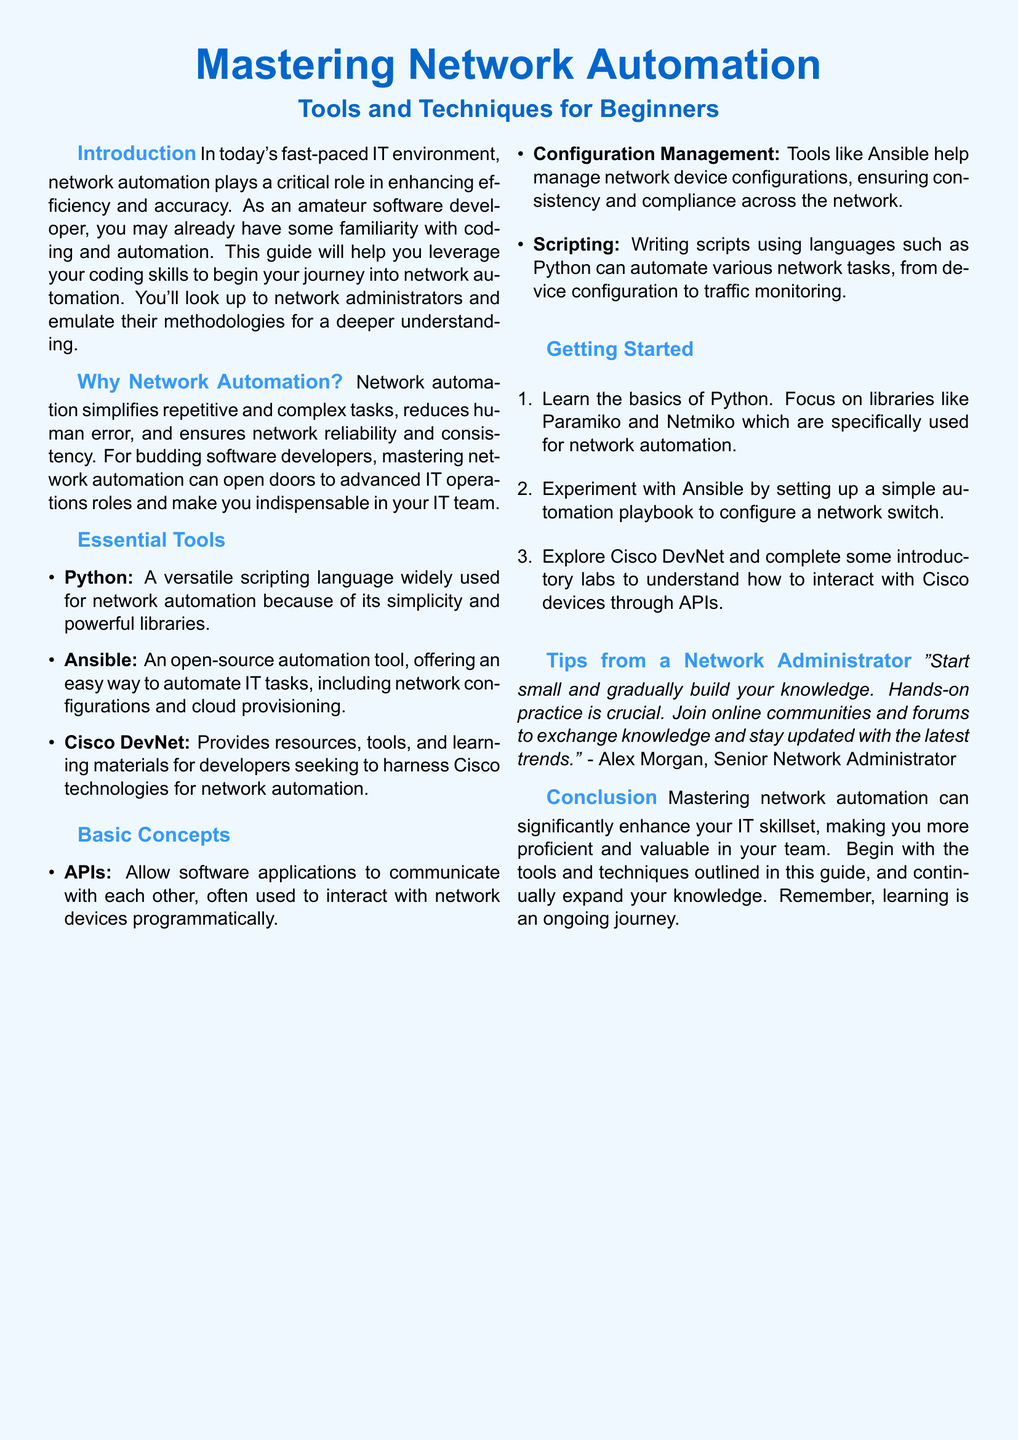What is the title of the document? The title appears prominently at the top of the document, indicating the main topic covered.
Answer: Mastering Network Automation What is the subtitle of the document? The subtitle provides additional context about the content aimed at a specific audience.
Answer: Tools and Techniques for Beginners Who is the author of the tip on network automation? The author of the tip is mentioned at the end of the Tips section, providing credibility to the advice given.
Answer: Alex Morgan What is one of the essential tools listed for network automation? The document lists various tools, and this is a straightforward retrieval question about one of them.
Answer: Python What is the first step in getting started with network automation? The getting started section outlines a sequence of steps, with the first one being crucial for learners.
Answer: Learn the basics of Python Which library is specifically mentioned for network automation with Python? The library is highlighted to emphasize its relevance in helping beginners with automation tasks.
Answer: Paramiko What is the main benefit of network automation mentioned in the document? The document clearly states the advantages of network automation, summarizing its impact on IT operations.
Answer: Reduces human error How does the document suggest to begin practicing network automation? This question relates to the practical advice given to encourage users to engage with the material actively.
Answer: Start small and gradually build your knowledge What type of programming language is Python described as? The document categorizes Python to showcase its suitability for the audience's skill level.
Answer: Versatile scripting language What does Ansible help manage in network automation? The document specifies a particular function that Ansible serves within the realm of network automation.
Answer: Network device configurations 